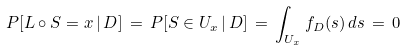<formula> <loc_0><loc_0><loc_500><loc_500>P [ L \circ S = x \, | \, D ] \, = \, P [ S \in U _ { x } \, | \, D ] \, = \, \int _ { U _ { x } } f _ { D } ( s ) \, d s \, = \, 0</formula> 